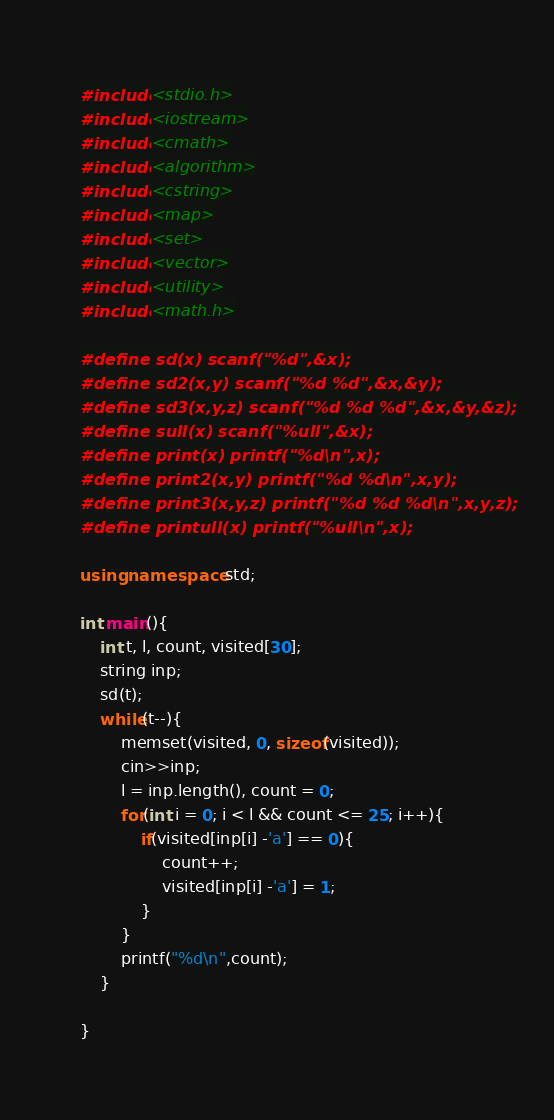Convert code to text. <code><loc_0><loc_0><loc_500><loc_500><_C++_>#include<stdio.h>
#include<iostream>
#include<cmath>
#include<algorithm>
#include<cstring>
#include<map>
#include<set>
#include<vector>
#include<utility>
#include<math.h>

#define sd(x) scanf("%d",&x);
#define sd2(x,y) scanf("%d %d",&x,&y);
#define sd3(x,y,z) scanf("%d %d %d",&x,&y,&z);
#define sull(x) scanf("%ull",&x);
#define print(x) printf("%d\n",x);
#define print2(x,y) printf("%d %d\n",x,y);
#define print3(x,y,z) printf("%d %d %d\n",x,y,z);
#define printull(x) printf("%ull\n",x);

using namespace std;

int main(){
	int t, l, count, visited[30];
	string inp;
	sd(t);
	while(t--){
		memset(visited, 0, sizeof(visited));
		cin>>inp;
		l = inp.length(), count = 0;
		for(int i = 0; i < l && count <= 25; i++){
			if(visited[inp[i] -'a'] == 0){
				count++;
				visited[inp[i] -'a'] = 1;
			}
		}
		printf("%d\n",count);
	}
	
}
</code> 